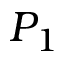Convert formula to latex. <formula><loc_0><loc_0><loc_500><loc_500>P _ { 1 }</formula> 